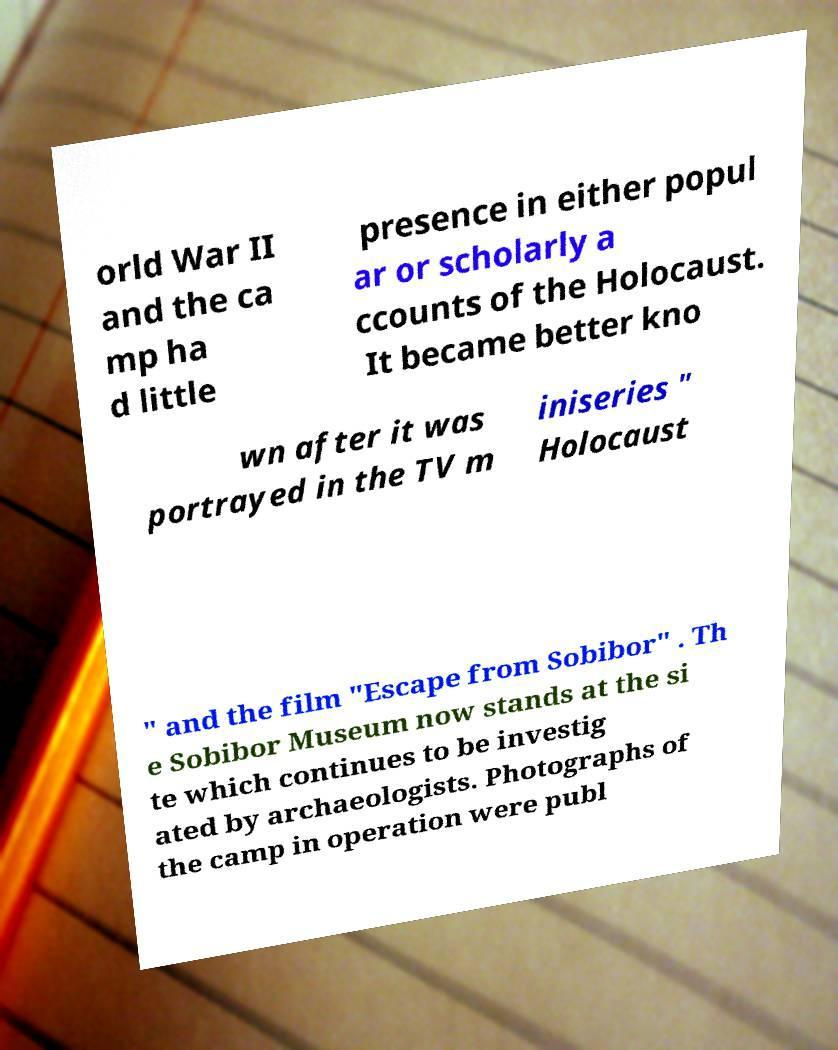Can you read and provide the text displayed in the image?This photo seems to have some interesting text. Can you extract and type it out for me? orld War II and the ca mp ha d little presence in either popul ar or scholarly a ccounts of the Holocaust. It became better kno wn after it was portrayed in the TV m iniseries " Holocaust " and the film "Escape from Sobibor" . Th e Sobibor Museum now stands at the si te which continues to be investig ated by archaeologists. Photographs of the camp in operation were publ 